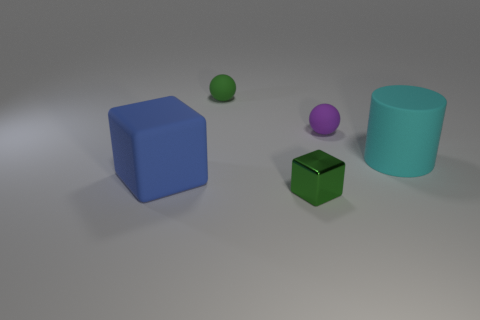There is a matte ball that is the same color as the metal cube; what is its size?
Offer a very short reply. Small. Do the large rubber object that is right of the green block and the matte object that is in front of the matte cylinder have the same color?
Keep it short and to the point. No. The cyan rubber cylinder has what size?
Provide a short and direct response. Large. How many big objects are purple balls or blue cubes?
Keep it short and to the point. 1. What color is the shiny block that is the same size as the purple rubber object?
Provide a short and direct response. Green. What number of other objects are there of the same shape as the big blue thing?
Make the answer very short. 1. Is there a tiny cube that has the same material as the large cylinder?
Make the answer very short. No. Is the large block on the left side of the purple thing made of the same material as the green thing behind the purple thing?
Offer a very short reply. Yes. How many small green shiny cylinders are there?
Offer a very short reply. 0. What shape is the large matte thing that is to the left of the green rubber object?
Provide a succinct answer. Cube. 